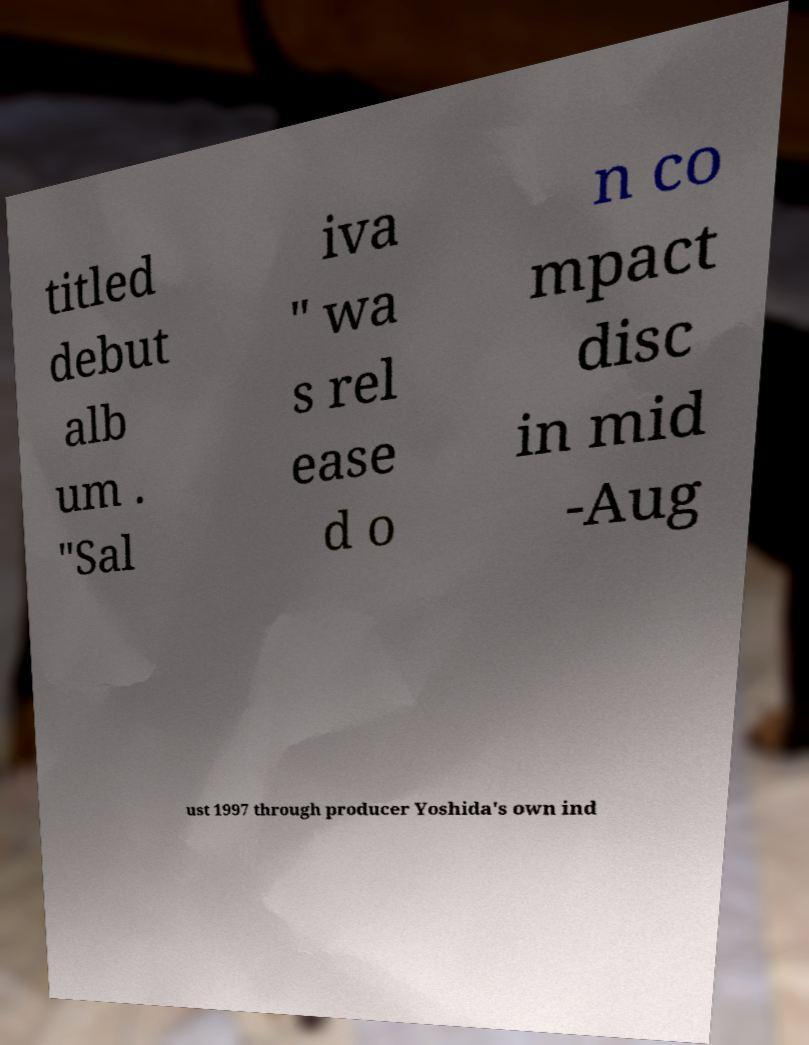Please identify and transcribe the text found in this image. titled debut alb um . "Sal iva " wa s rel ease d o n co mpact disc in mid -Aug ust 1997 through producer Yoshida's own ind 